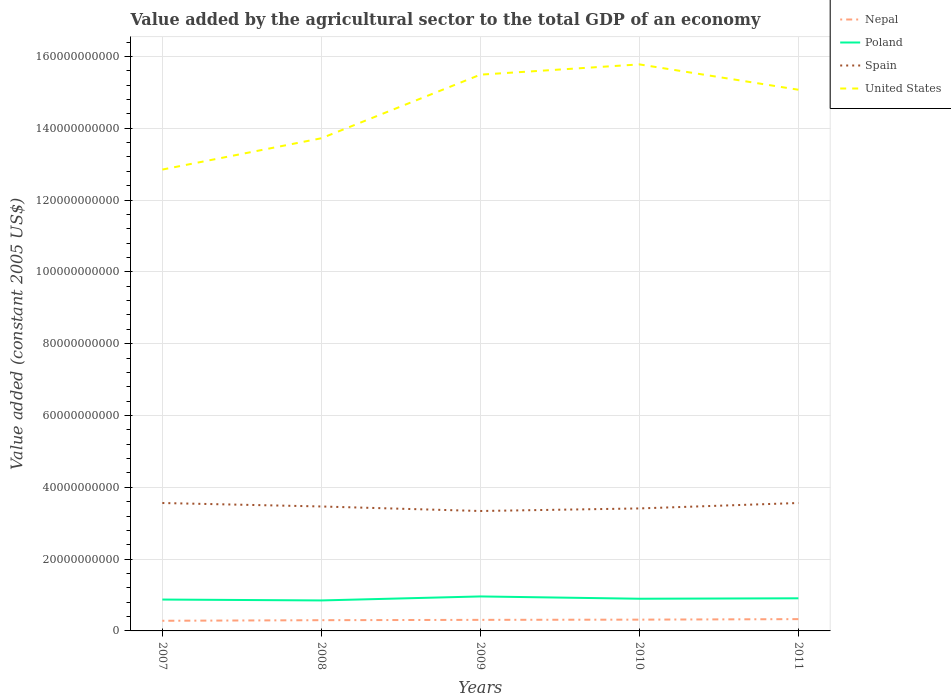Is the number of lines equal to the number of legend labels?
Offer a terse response. Yes. Across all years, what is the maximum value added by the agricultural sector in Nepal?
Provide a succinct answer. 2.83e+09. In which year was the value added by the agricultural sector in Nepal maximum?
Keep it short and to the point. 2007. What is the total value added by the agricultural sector in Spain in the graph?
Ensure brevity in your answer.  9.66e+08. What is the difference between the highest and the second highest value added by the agricultural sector in Spain?
Provide a succinct answer. 2.23e+09. Are the values on the major ticks of Y-axis written in scientific E-notation?
Provide a succinct answer. No. Does the graph contain any zero values?
Offer a very short reply. No. Does the graph contain grids?
Provide a short and direct response. Yes. Where does the legend appear in the graph?
Provide a succinct answer. Top right. What is the title of the graph?
Make the answer very short. Value added by the agricultural sector to the total GDP of an economy. Does "Iran" appear as one of the legend labels in the graph?
Offer a terse response. No. What is the label or title of the Y-axis?
Ensure brevity in your answer.  Value added (constant 2005 US$). What is the Value added (constant 2005 US$) of Nepal in 2007?
Make the answer very short. 2.83e+09. What is the Value added (constant 2005 US$) in Poland in 2007?
Keep it short and to the point. 8.74e+09. What is the Value added (constant 2005 US$) in Spain in 2007?
Make the answer very short. 3.56e+1. What is the Value added (constant 2005 US$) of United States in 2007?
Ensure brevity in your answer.  1.28e+11. What is the Value added (constant 2005 US$) in Nepal in 2008?
Offer a terse response. 2.99e+09. What is the Value added (constant 2005 US$) of Poland in 2008?
Ensure brevity in your answer.  8.49e+09. What is the Value added (constant 2005 US$) in Spain in 2008?
Keep it short and to the point. 3.47e+1. What is the Value added (constant 2005 US$) of United States in 2008?
Offer a terse response. 1.37e+11. What is the Value added (constant 2005 US$) in Nepal in 2009?
Offer a terse response. 3.08e+09. What is the Value added (constant 2005 US$) of Poland in 2009?
Your response must be concise. 9.60e+09. What is the Value added (constant 2005 US$) of Spain in 2009?
Give a very brief answer. 3.34e+1. What is the Value added (constant 2005 US$) of United States in 2009?
Make the answer very short. 1.55e+11. What is the Value added (constant 2005 US$) of Nepal in 2010?
Provide a succinct answer. 3.14e+09. What is the Value added (constant 2005 US$) in Poland in 2010?
Offer a terse response. 8.96e+09. What is the Value added (constant 2005 US$) in Spain in 2010?
Your answer should be compact. 3.41e+1. What is the Value added (constant 2005 US$) in United States in 2010?
Provide a short and direct response. 1.58e+11. What is the Value added (constant 2005 US$) in Nepal in 2011?
Your answer should be compact. 3.28e+09. What is the Value added (constant 2005 US$) of Poland in 2011?
Offer a terse response. 9.08e+09. What is the Value added (constant 2005 US$) in Spain in 2011?
Provide a succinct answer. 3.56e+1. What is the Value added (constant 2005 US$) in United States in 2011?
Make the answer very short. 1.51e+11. Across all years, what is the maximum Value added (constant 2005 US$) in Nepal?
Offer a terse response. 3.28e+09. Across all years, what is the maximum Value added (constant 2005 US$) in Poland?
Give a very brief answer. 9.60e+09. Across all years, what is the maximum Value added (constant 2005 US$) in Spain?
Keep it short and to the point. 3.56e+1. Across all years, what is the maximum Value added (constant 2005 US$) in United States?
Provide a succinct answer. 1.58e+11. Across all years, what is the minimum Value added (constant 2005 US$) of Nepal?
Offer a terse response. 2.83e+09. Across all years, what is the minimum Value added (constant 2005 US$) of Poland?
Give a very brief answer. 8.49e+09. Across all years, what is the minimum Value added (constant 2005 US$) in Spain?
Ensure brevity in your answer.  3.34e+1. Across all years, what is the minimum Value added (constant 2005 US$) in United States?
Ensure brevity in your answer.  1.28e+11. What is the total Value added (constant 2005 US$) in Nepal in the graph?
Provide a succinct answer. 1.53e+1. What is the total Value added (constant 2005 US$) of Poland in the graph?
Offer a terse response. 4.49e+1. What is the total Value added (constant 2005 US$) in Spain in the graph?
Offer a terse response. 1.73e+11. What is the total Value added (constant 2005 US$) of United States in the graph?
Offer a very short reply. 7.29e+11. What is the difference between the Value added (constant 2005 US$) in Nepal in 2007 and that in 2008?
Provide a succinct answer. -1.65e+08. What is the difference between the Value added (constant 2005 US$) in Poland in 2007 and that in 2008?
Ensure brevity in your answer.  2.45e+08. What is the difference between the Value added (constant 2005 US$) of Spain in 2007 and that in 2008?
Keep it short and to the point. 9.66e+08. What is the difference between the Value added (constant 2005 US$) of United States in 2007 and that in 2008?
Give a very brief answer. -8.72e+09. What is the difference between the Value added (constant 2005 US$) in Nepal in 2007 and that in 2009?
Your answer should be very brief. -2.55e+08. What is the difference between the Value added (constant 2005 US$) of Poland in 2007 and that in 2009?
Keep it short and to the point. -8.69e+08. What is the difference between the Value added (constant 2005 US$) of Spain in 2007 and that in 2009?
Your answer should be very brief. 2.22e+09. What is the difference between the Value added (constant 2005 US$) in United States in 2007 and that in 2009?
Your answer should be very brief. -2.64e+1. What is the difference between the Value added (constant 2005 US$) in Nepal in 2007 and that in 2010?
Ensure brevity in your answer.  -3.17e+08. What is the difference between the Value added (constant 2005 US$) in Poland in 2007 and that in 2010?
Offer a very short reply. -2.27e+08. What is the difference between the Value added (constant 2005 US$) in Spain in 2007 and that in 2010?
Your answer should be very brief. 1.51e+09. What is the difference between the Value added (constant 2005 US$) in United States in 2007 and that in 2010?
Offer a very short reply. -2.93e+1. What is the difference between the Value added (constant 2005 US$) in Nepal in 2007 and that in 2011?
Your answer should be very brief. -4.59e+08. What is the difference between the Value added (constant 2005 US$) in Poland in 2007 and that in 2011?
Your answer should be compact. -3.48e+08. What is the difference between the Value added (constant 2005 US$) in Spain in 2007 and that in 2011?
Provide a short and direct response. -2.70e+06. What is the difference between the Value added (constant 2005 US$) in United States in 2007 and that in 2011?
Offer a terse response. -2.22e+1. What is the difference between the Value added (constant 2005 US$) of Nepal in 2008 and that in 2009?
Your answer should be very brief. -9.03e+07. What is the difference between the Value added (constant 2005 US$) of Poland in 2008 and that in 2009?
Offer a terse response. -1.11e+09. What is the difference between the Value added (constant 2005 US$) in Spain in 2008 and that in 2009?
Provide a short and direct response. 1.26e+09. What is the difference between the Value added (constant 2005 US$) of United States in 2008 and that in 2009?
Your response must be concise. -1.77e+1. What is the difference between the Value added (constant 2005 US$) in Nepal in 2008 and that in 2010?
Provide a short and direct response. -1.52e+08. What is the difference between the Value added (constant 2005 US$) of Poland in 2008 and that in 2010?
Offer a terse response. -4.72e+08. What is the difference between the Value added (constant 2005 US$) of Spain in 2008 and that in 2010?
Your answer should be compact. 5.44e+08. What is the difference between the Value added (constant 2005 US$) of United States in 2008 and that in 2010?
Offer a very short reply. -2.06e+1. What is the difference between the Value added (constant 2005 US$) in Nepal in 2008 and that in 2011?
Provide a succinct answer. -2.94e+08. What is the difference between the Value added (constant 2005 US$) in Poland in 2008 and that in 2011?
Offer a very short reply. -5.93e+08. What is the difference between the Value added (constant 2005 US$) in Spain in 2008 and that in 2011?
Keep it short and to the point. -9.69e+08. What is the difference between the Value added (constant 2005 US$) in United States in 2008 and that in 2011?
Give a very brief answer. -1.35e+1. What is the difference between the Value added (constant 2005 US$) of Nepal in 2009 and that in 2010?
Keep it short and to the point. -6.20e+07. What is the difference between the Value added (constant 2005 US$) in Poland in 2009 and that in 2010?
Offer a very short reply. 6.42e+08. What is the difference between the Value added (constant 2005 US$) in Spain in 2009 and that in 2010?
Your answer should be very brief. -7.15e+08. What is the difference between the Value added (constant 2005 US$) of United States in 2009 and that in 2010?
Your answer should be very brief. -2.86e+09. What is the difference between the Value added (constant 2005 US$) in Nepal in 2009 and that in 2011?
Provide a short and direct response. -2.04e+08. What is the difference between the Value added (constant 2005 US$) of Poland in 2009 and that in 2011?
Make the answer very short. 5.21e+08. What is the difference between the Value added (constant 2005 US$) in Spain in 2009 and that in 2011?
Keep it short and to the point. -2.23e+09. What is the difference between the Value added (constant 2005 US$) in United States in 2009 and that in 2011?
Provide a succinct answer. 4.20e+09. What is the difference between the Value added (constant 2005 US$) in Nepal in 2010 and that in 2011?
Make the answer very short. -1.42e+08. What is the difference between the Value added (constant 2005 US$) in Poland in 2010 and that in 2011?
Your answer should be compact. -1.21e+08. What is the difference between the Value added (constant 2005 US$) in Spain in 2010 and that in 2011?
Give a very brief answer. -1.51e+09. What is the difference between the Value added (constant 2005 US$) of United States in 2010 and that in 2011?
Your answer should be compact. 7.06e+09. What is the difference between the Value added (constant 2005 US$) in Nepal in 2007 and the Value added (constant 2005 US$) in Poland in 2008?
Provide a short and direct response. -5.66e+09. What is the difference between the Value added (constant 2005 US$) of Nepal in 2007 and the Value added (constant 2005 US$) of Spain in 2008?
Offer a terse response. -3.18e+1. What is the difference between the Value added (constant 2005 US$) in Nepal in 2007 and the Value added (constant 2005 US$) in United States in 2008?
Offer a very short reply. -1.34e+11. What is the difference between the Value added (constant 2005 US$) in Poland in 2007 and the Value added (constant 2005 US$) in Spain in 2008?
Keep it short and to the point. -2.59e+1. What is the difference between the Value added (constant 2005 US$) of Poland in 2007 and the Value added (constant 2005 US$) of United States in 2008?
Provide a short and direct response. -1.28e+11. What is the difference between the Value added (constant 2005 US$) in Spain in 2007 and the Value added (constant 2005 US$) in United States in 2008?
Make the answer very short. -1.02e+11. What is the difference between the Value added (constant 2005 US$) in Nepal in 2007 and the Value added (constant 2005 US$) in Poland in 2009?
Ensure brevity in your answer.  -6.78e+09. What is the difference between the Value added (constant 2005 US$) of Nepal in 2007 and the Value added (constant 2005 US$) of Spain in 2009?
Your answer should be compact. -3.06e+1. What is the difference between the Value added (constant 2005 US$) of Nepal in 2007 and the Value added (constant 2005 US$) of United States in 2009?
Your response must be concise. -1.52e+11. What is the difference between the Value added (constant 2005 US$) in Poland in 2007 and the Value added (constant 2005 US$) in Spain in 2009?
Give a very brief answer. -2.47e+1. What is the difference between the Value added (constant 2005 US$) in Poland in 2007 and the Value added (constant 2005 US$) in United States in 2009?
Give a very brief answer. -1.46e+11. What is the difference between the Value added (constant 2005 US$) in Spain in 2007 and the Value added (constant 2005 US$) in United States in 2009?
Make the answer very short. -1.19e+11. What is the difference between the Value added (constant 2005 US$) in Nepal in 2007 and the Value added (constant 2005 US$) in Poland in 2010?
Provide a short and direct response. -6.14e+09. What is the difference between the Value added (constant 2005 US$) in Nepal in 2007 and the Value added (constant 2005 US$) in Spain in 2010?
Give a very brief answer. -3.13e+1. What is the difference between the Value added (constant 2005 US$) in Nepal in 2007 and the Value added (constant 2005 US$) in United States in 2010?
Offer a terse response. -1.55e+11. What is the difference between the Value added (constant 2005 US$) of Poland in 2007 and the Value added (constant 2005 US$) of Spain in 2010?
Ensure brevity in your answer.  -2.54e+1. What is the difference between the Value added (constant 2005 US$) of Poland in 2007 and the Value added (constant 2005 US$) of United States in 2010?
Keep it short and to the point. -1.49e+11. What is the difference between the Value added (constant 2005 US$) of Spain in 2007 and the Value added (constant 2005 US$) of United States in 2010?
Provide a short and direct response. -1.22e+11. What is the difference between the Value added (constant 2005 US$) in Nepal in 2007 and the Value added (constant 2005 US$) in Poland in 2011?
Your response must be concise. -6.26e+09. What is the difference between the Value added (constant 2005 US$) in Nepal in 2007 and the Value added (constant 2005 US$) in Spain in 2011?
Your answer should be compact. -3.28e+1. What is the difference between the Value added (constant 2005 US$) in Nepal in 2007 and the Value added (constant 2005 US$) in United States in 2011?
Provide a short and direct response. -1.48e+11. What is the difference between the Value added (constant 2005 US$) of Poland in 2007 and the Value added (constant 2005 US$) of Spain in 2011?
Your answer should be compact. -2.69e+1. What is the difference between the Value added (constant 2005 US$) of Poland in 2007 and the Value added (constant 2005 US$) of United States in 2011?
Give a very brief answer. -1.42e+11. What is the difference between the Value added (constant 2005 US$) of Spain in 2007 and the Value added (constant 2005 US$) of United States in 2011?
Provide a short and direct response. -1.15e+11. What is the difference between the Value added (constant 2005 US$) in Nepal in 2008 and the Value added (constant 2005 US$) in Poland in 2009?
Your answer should be very brief. -6.61e+09. What is the difference between the Value added (constant 2005 US$) in Nepal in 2008 and the Value added (constant 2005 US$) in Spain in 2009?
Keep it short and to the point. -3.04e+1. What is the difference between the Value added (constant 2005 US$) of Nepal in 2008 and the Value added (constant 2005 US$) of United States in 2009?
Your answer should be very brief. -1.52e+11. What is the difference between the Value added (constant 2005 US$) of Poland in 2008 and the Value added (constant 2005 US$) of Spain in 2009?
Provide a short and direct response. -2.49e+1. What is the difference between the Value added (constant 2005 US$) of Poland in 2008 and the Value added (constant 2005 US$) of United States in 2009?
Your answer should be very brief. -1.46e+11. What is the difference between the Value added (constant 2005 US$) in Spain in 2008 and the Value added (constant 2005 US$) in United States in 2009?
Provide a short and direct response. -1.20e+11. What is the difference between the Value added (constant 2005 US$) in Nepal in 2008 and the Value added (constant 2005 US$) in Poland in 2010?
Your response must be concise. -5.97e+09. What is the difference between the Value added (constant 2005 US$) in Nepal in 2008 and the Value added (constant 2005 US$) in Spain in 2010?
Make the answer very short. -3.11e+1. What is the difference between the Value added (constant 2005 US$) of Nepal in 2008 and the Value added (constant 2005 US$) of United States in 2010?
Give a very brief answer. -1.55e+11. What is the difference between the Value added (constant 2005 US$) in Poland in 2008 and the Value added (constant 2005 US$) in Spain in 2010?
Offer a very short reply. -2.56e+1. What is the difference between the Value added (constant 2005 US$) in Poland in 2008 and the Value added (constant 2005 US$) in United States in 2010?
Make the answer very short. -1.49e+11. What is the difference between the Value added (constant 2005 US$) in Spain in 2008 and the Value added (constant 2005 US$) in United States in 2010?
Offer a terse response. -1.23e+11. What is the difference between the Value added (constant 2005 US$) in Nepal in 2008 and the Value added (constant 2005 US$) in Poland in 2011?
Your answer should be very brief. -6.09e+09. What is the difference between the Value added (constant 2005 US$) in Nepal in 2008 and the Value added (constant 2005 US$) in Spain in 2011?
Give a very brief answer. -3.26e+1. What is the difference between the Value added (constant 2005 US$) of Nepal in 2008 and the Value added (constant 2005 US$) of United States in 2011?
Make the answer very short. -1.48e+11. What is the difference between the Value added (constant 2005 US$) of Poland in 2008 and the Value added (constant 2005 US$) of Spain in 2011?
Offer a very short reply. -2.71e+1. What is the difference between the Value added (constant 2005 US$) in Poland in 2008 and the Value added (constant 2005 US$) in United States in 2011?
Offer a terse response. -1.42e+11. What is the difference between the Value added (constant 2005 US$) in Spain in 2008 and the Value added (constant 2005 US$) in United States in 2011?
Your answer should be compact. -1.16e+11. What is the difference between the Value added (constant 2005 US$) in Nepal in 2009 and the Value added (constant 2005 US$) in Poland in 2010?
Provide a succinct answer. -5.88e+09. What is the difference between the Value added (constant 2005 US$) in Nepal in 2009 and the Value added (constant 2005 US$) in Spain in 2010?
Keep it short and to the point. -3.10e+1. What is the difference between the Value added (constant 2005 US$) of Nepal in 2009 and the Value added (constant 2005 US$) of United States in 2010?
Provide a succinct answer. -1.55e+11. What is the difference between the Value added (constant 2005 US$) of Poland in 2009 and the Value added (constant 2005 US$) of Spain in 2010?
Make the answer very short. -2.45e+1. What is the difference between the Value added (constant 2005 US$) of Poland in 2009 and the Value added (constant 2005 US$) of United States in 2010?
Provide a short and direct response. -1.48e+11. What is the difference between the Value added (constant 2005 US$) in Spain in 2009 and the Value added (constant 2005 US$) in United States in 2010?
Give a very brief answer. -1.24e+11. What is the difference between the Value added (constant 2005 US$) in Nepal in 2009 and the Value added (constant 2005 US$) in Poland in 2011?
Keep it short and to the point. -6.00e+09. What is the difference between the Value added (constant 2005 US$) in Nepal in 2009 and the Value added (constant 2005 US$) in Spain in 2011?
Offer a terse response. -3.25e+1. What is the difference between the Value added (constant 2005 US$) in Nepal in 2009 and the Value added (constant 2005 US$) in United States in 2011?
Your answer should be compact. -1.48e+11. What is the difference between the Value added (constant 2005 US$) in Poland in 2009 and the Value added (constant 2005 US$) in Spain in 2011?
Ensure brevity in your answer.  -2.60e+1. What is the difference between the Value added (constant 2005 US$) of Poland in 2009 and the Value added (constant 2005 US$) of United States in 2011?
Your answer should be very brief. -1.41e+11. What is the difference between the Value added (constant 2005 US$) of Spain in 2009 and the Value added (constant 2005 US$) of United States in 2011?
Your response must be concise. -1.17e+11. What is the difference between the Value added (constant 2005 US$) of Nepal in 2010 and the Value added (constant 2005 US$) of Poland in 2011?
Provide a short and direct response. -5.94e+09. What is the difference between the Value added (constant 2005 US$) of Nepal in 2010 and the Value added (constant 2005 US$) of Spain in 2011?
Ensure brevity in your answer.  -3.25e+1. What is the difference between the Value added (constant 2005 US$) in Nepal in 2010 and the Value added (constant 2005 US$) in United States in 2011?
Offer a terse response. -1.48e+11. What is the difference between the Value added (constant 2005 US$) of Poland in 2010 and the Value added (constant 2005 US$) of Spain in 2011?
Give a very brief answer. -2.67e+1. What is the difference between the Value added (constant 2005 US$) of Poland in 2010 and the Value added (constant 2005 US$) of United States in 2011?
Offer a terse response. -1.42e+11. What is the difference between the Value added (constant 2005 US$) in Spain in 2010 and the Value added (constant 2005 US$) in United States in 2011?
Keep it short and to the point. -1.17e+11. What is the average Value added (constant 2005 US$) in Nepal per year?
Make the answer very short. 3.07e+09. What is the average Value added (constant 2005 US$) in Poland per year?
Your answer should be compact. 8.98e+09. What is the average Value added (constant 2005 US$) in Spain per year?
Offer a very short reply. 3.47e+1. What is the average Value added (constant 2005 US$) of United States per year?
Provide a short and direct response. 1.46e+11. In the year 2007, what is the difference between the Value added (constant 2005 US$) in Nepal and Value added (constant 2005 US$) in Poland?
Your response must be concise. -5.91e+09. In the year 2007, what is the difference between the Value added (constant 2005 US$) of Nepal and Value added (constant 2005 US$) of Spain?
Your answer should be compact. -3.28e+1. In the year 2007, what is the difference between the Value added (constant 2005 US$) of Nepal and Value added (constant 2005 US$) of United States?
Offer a very short reply. -1.26e+11. In the year 2007, what is the difference between the Value added (constant 2005 US$) of Poland and Value added (constant 2005 US$) of Spain?
Ensure brevity in your answer.  -2.69e+1. In the year 2007, what is the difference between the Value added (constant 2005 US$) of Poland and Value added (constant 2005 US$) of United States?
Give a very brief answer. -1.20e+11. In the year 2007, what is the difference between the Value added (constant 2005 US$) of Spain and Value added (constant 2005 US$) of United States?
Offer a terse response. -9.29e+1. In the year 2008, what is the difference between the Value added (constant 2005 US$) in Nepal and Value added (constant 2005 US$) in Poland?
Offer a very short reply. -5.50e+09. In the year 2008, what is the difference between the Value added (constant 2005 US$) in Nepal and Value added (constant 2005 US$) in Spain?
Give a very brief answer. -3.17e+1. In the year 2008, what is the difference between the Value added (constant 2005 US$) in Nepal and Value added (constant 2005 US$) in United States?
Your response must be concise. -1.34e+11. In the year 2008, what is the difference between the Value added (constant 2005 US$) in Poland and Value added (constant 2005 US$) in Spain?
Offer a very short reply. -2.62e+1. In the year 2008, what is the difference between the Value added (constant 2005 US$) of Poland and Value added (constant 2005 US$) of United States?
Provide a succinct answer. -1.29e+11. In the year 2008, what is the difference between the Value added (constant 2005 US$) of Spain and Value added (constant 2005 US$) of United States?
Provide a succinct answer. -1.03e+11. In the year 2009, what is the difference between the Value added (constant 2005 US$) in Nepal and Value added (constant 2005 US$) in Poland?
Provide a short and direct response. -6.52e+09. In the year 2009, what is the difference between the Value added (constant 2005 US$) in Nepal and Value added (constant 2005 US$) in Spain?
Offer a very short reply. -3.03e+1. In the year 2009, what is the difference between the Value added (constant 2005 US$) of Nepal and Value added (constant 2005 US$) of United States?
Make the answer very short. -1.52e+11. In the year 2009, what is the difference between the Value added (constant 2005 US$) of Poland and Value added (constant 2005 US$) of Spain?
Keep it short and to the point. -2.38e+1. In the year 2009, what is the difference between the Value added (constant 2005 US$) of Poland and Value added (constant 2005 US$) of United States?
Your answer should be compact. -1.45e+11. In the year 2009, what is the difference between the Value added (constant 2005 US$) in Spain and Value added (constant 2005 US$) in United States?
Your answer should be compact. -1.22e+11. In the year 2010, what is the difference between the Value added (constant 2005 US$) in Nepal and Value added (constant 2005 US$) in Poland?
Offer a very short reply. -5.82e+09. In the year 2010, what is the difference between the Value added (constant 2005 US$) in Nepal and Value added (constant 2005 US$) in Spain?
Ensure brevity in your answer.  -3.10e+1. In the year 2010, what is the difference between the Value added (constant 2005 US$) of Nepal and Value added (constant 2005 US$) of United States?
Ensure brevity in your answer.  -1.55e+11. In the year 2010, what is the difference between the Value added (constant 2005 US$) of Poland and Value added (constant 2005 US$) of Spain?
Your response must be concise. -2.52e+1. In the year 2010, what is the difference between the Value added (constant 2005 US$) of Poland and Value added (constant 2005 US$) of United States?
Keep it short and to the point. -1.49e+11. In the year 2010, what is the difference between the Value added (constant 2005 US$) in Spain and Value added (constant 2005 US$) in United States?
Give a very brief answer. -1.24e+11. In the year 2011, what is the difference between the Value added (constant 2005 US$) of Nepal and Value added (constant 2005 US$) of Poland?
Your response must be concise. -5.80e+09. In the year 2011, what is the difference between the Value added (constant 2005 US$) of Nepal and Value added (constant 2005 US$) of Spain?
Keep it short and to the point. -3.23e+1. In the year 2011, what is the difference between the Value added (constant 2005 US$) in Nepal and Value added (constant 2005 US$) in United States?
Ensure brevity in your answer.  -1.47e+11. In the year 2011, what is the difference between the Value added (constant 2005 US$) in Poland and Value added (constant 2005 US$) in Spain?
Make the answer very short. -2.65e+1. In the year 2011, what is the difference between the Value added (constant 2005 US$) in Poland and Value added (constant 2005 US$) in United States?
Your response must be concise. -1.42e+11. In the year 2011, what is the difference between the Value added (constant 2005 US$) in Spain and Value added (constant 2005 US$) in United States?
Ensure brevity in your answer.  -1.15e+11. What is the ratio of the Value added (constant 2005 US$) of Nepal in 2007 to that in 2008?
Offer a very short reply. 0.94. What is the ratio of the Value added (constant 2005 US$) of Poland in 2007 to that in 2008?
Offer a terse response. 1.03. What is the ratio of the Value added (constant 2005 US$) of Spain in 2007 to that in 2008?
Offer a terse response. 1.03. What is the ratio of the Value added (constant 2005 US$) of United States in 2007 to that in 2008?
Ensure brevity in your answer.  0.94. What is the ratio of the Value added (constant 2005 US$) of Nepal in 2007 to that in 2009?
Offer a terse response. 0.92. What is the ratio of the Value added (constant 2005 US$) in Poland in 2007 to that in 2009?
Provide a succinct answer. 0.91. What is the ratio of the Value added (constant 2005 US$) of Spain in 2007 to that in 2009?
Make the answer very short. 1.07. What is the ratio of the Value added (constant 2005 US$) of United States in 2007 to that in 2009?
Offer a terse response. 0.83. What is the ratio of the Value added (constant 2005 US$) in Nepal in 2007 to that in 2010?
Make the answer very short. 0.9. What is the ratio of the Value added (constant 2005 US$) of Poland in 2007 to that in 2010?
Ensure brevity in your answer.  0.97. What is the ratio of the Value added (constant 2005 US$) of Spain in 2007 to that in 2010?
Provide a short and direct response. 1.04. What is the ratio of the Value added (constant 2005 US$) of United States in 2007 to that in 2010?
Your answer should be very brief. 0.81. What is the ratio of the Value added (constant 2005 US$) of Nepal in 2007 to that in 2011?
Ensure brevity in your answer.  0.86. What is the ratio of the Value added (constant 2005 US$) of Poland in 2007 to that in 2011?
Your response must be concise. 0.96. What is the ratio of the Value added (constant 2005 US$) in Spain in 2007 to that in 2011?
Provide a succinct answer. 1. What is the ratio of the Value added (constant 2005 US$) of United States in 2007 to that in 2011?
Provide a short and direct response. 0.85. What is the ratio of the Value added (constant 2005 US$) in Nepal in 2008 to that in 2009?
Ensure brevity in your answer.  0.97. What is the ratio of the Value added (constant 2005 US$) in Poland in 2008 to that in 2009?
Offer a very short reply. 0.88. What is the ratio of the Value added (constant 2005 US$) of Spain in 2008 to that in 2009?
Offer a very short reply. 1.04. What is the ratio of the Value added (constant 2005 US$) of United States in 2008 to that in 2009?
Offer a terse response. 0.89. What is the ratio of the Value added (constant 2005 US$) of Nepal in 2008 to that in 2010?
Provide a short and direct response. 0.95. What is the ratio of the Value added (constant 2005 US$) of Poland in 2008 to that in 2010?
Offer a terse response. 0.95. What is the ratio of the Value added (constant 2005 US$) of United States in 2008 to that in 2010?
Offer a very short reply. 0.87. What is the ratio of the Value added (constant 2005 US$) in Nepal in 2008 to that in 2011?
Provide a succinct answer. 0.91. What is the ratio of the Value added (constant 2005 US$) in Poland in 2008 to that in 2011?
Your answer should be very brief. 0.93. What is the ratio of the Value added (constant 2005 US$) in Spain in 2008 to that in 2011?
Provide a short and direct response. 0.97. What is the ratio of the Value added (constant 2005 US$) of United States in 2008 to that in 2011?
Ensure brevity in your answer.  0.91. What is the ratio of the Value added (constant 2005 US$) in Nepal in 2009 to that in 2010?
Provide a short and direct response. 0.98. What is the ratio of the Value added (constant 2005 US$) of Poland in 2009 to that in 2010?
Keep it short and to the point. 1.07. What is the ratio of the Value added (constant 2005 US$) in Spain in 2009 to that in 2010?
Provide a succinct answer. 0.98. What is the ratio of the Value added (constant 2005 US$) of United States in 2009 to that in 2010?
Provide a short and direct response. 0.98. What is the ratio of the Value added (constant 2005 US$) in Nepal in 2009 to that in 2011?
Ensure brevity in your answer.  0.94. What is the ratio of the Value added (constant 2005 US$) in Poland in 2009 to that in 2011?
Provide a succinct answer. 1.06. What is the ratio of the Value added (constant 2005 US$) of United States in 2009 to that in 2011?
Offer a terse response. 1.03. What is the ratio of the Value added (constant 2005 US$) in Nepal in 2010 to that in 2011?
Give a very brief answer. 0.96. What is the ratio of the Value added (constant 2005 US$) of Poland in 2010 to that in 2011?
Your answer should be compact. 0.99. What is the ratio of the Value added (constant 2005 US$) of Spain in 2010 to that in 2011?
Keep it short and to the point. 0.96. What is the ratio of the Value added (constant 2005 US$) in United States in 2010 to that in 2011?
Your answer should be very brief. 1.05. What is the difference between the highest and the second highest Value added (constant 2005 US$) of Nepal?
Make the answer very short. 1.42e+08. What is the difference between the highest and the second highest Value added (constant 2005 US$) in Poland?
Make the answer very short. 5.21e+08. What is the difference between the highest and the second highest Value added (constant 2005 US$) in Spain?
Your answer should be compact. 2.70e+06. What is the difference between the highest and the second highest Value added (constant 2005 US$) in United States?
Provide a short and direct response. 2.86e+09. What is the difference between the highest and the lowest Value added (constant 2005 US$) of Nepal?
Your response must be concise. 4.59e+08. What is the difference between the highest and the lowest Value added (constant 2005 US$) in Poland?
Make the answer very short. 1.11e+09. What is the difference between the highest and the lowest Value added (constant 2005 US$) in Spain?
Offer a terse response. 2.23e+09. What is the difference between the highest and the lowest Value added (constant 2005 US$) in United States?
Your answer should be very brief. 2.93e+1. 